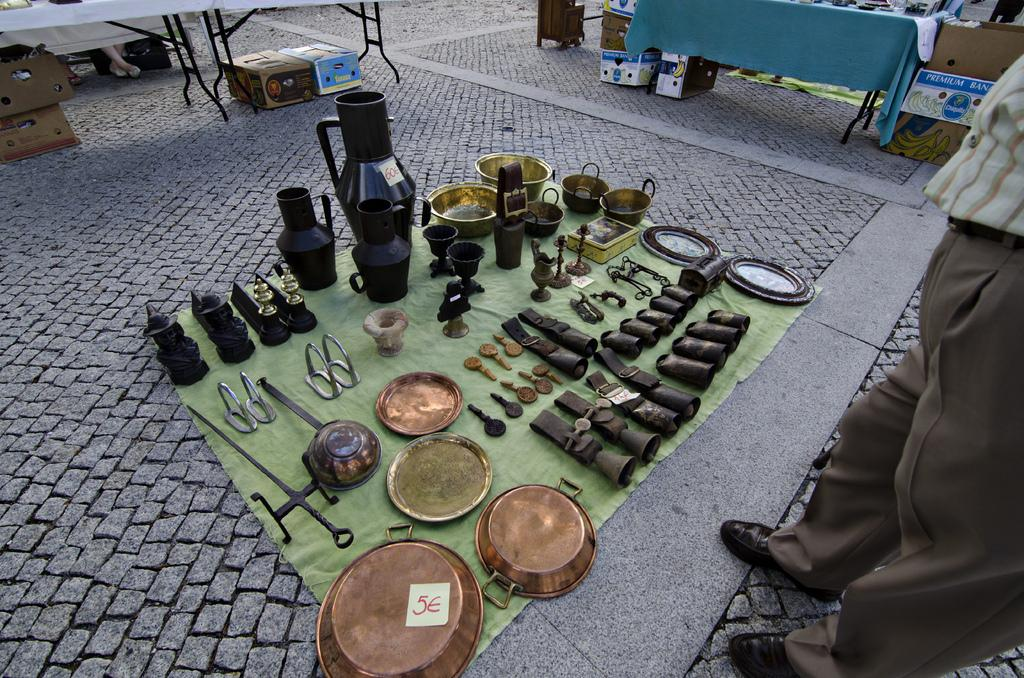What type of vessels are on the ground in the image? There are copper vessels on the ground. Who is standing in front of the vessels? A man is standing in front of the vessels. What can be seen on the table in the image? There is a table in the image, and there is a cloth on the table. What else is present in the image besides the vessels and table? There are cartons present. Can you describe the truck that is parked next to the man in the image? There is no truck present in the image; it only features copper vessels, a man, a table, a cloth, and cartons. What type of tiger can be seen sitting on the table in the image? There is no tiger present in the image; only the copper vessels, man, table, cloth, and cartons are visible. 